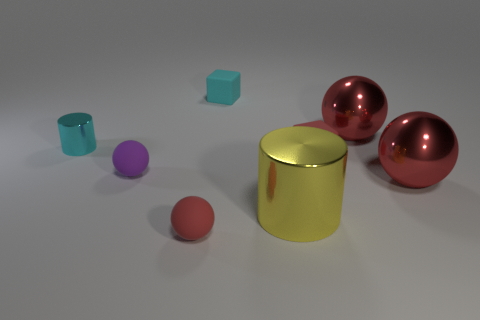Subtract all red spheres. How many were subtracted if there are1red spheres left? 2 Subtract all small red spheres. How many spheres are left? 3 Subtract all cubes. How many objects are left? 6 Subtract all yellow cylinders. How many cylinders are left? 1 Subtract all yellow blocks. How many red balls are left? 3 Add 1 small purple metal cubes. How many objects exist? 9 Subtract all red cylinders. Subtract all gray balls. How many cylinders are left? 2 Subtract all cyan cubes. Subtract all cyan objects. How many objects are left? 5 Add 1 small purple spheres. How many small purple spheres are left? 2 Add 1 cylinders. How many cylinders exist? 3 